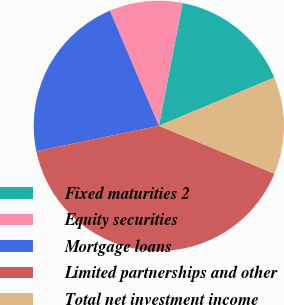Convert chart. <chart><loc_0><loc_0><loc_500><loc_500><pie_chart><fcel>Fixed maturities 2<fcel>Equity securities<fcel>Mortgage loans<fcel>Limited partnerships and other<fcel>Total net investment income<nl><fcel>15.65%<fcel>9.45%<fcel>21.86%<fcel>40.49%<fcel>12.55%<nl></chart> 